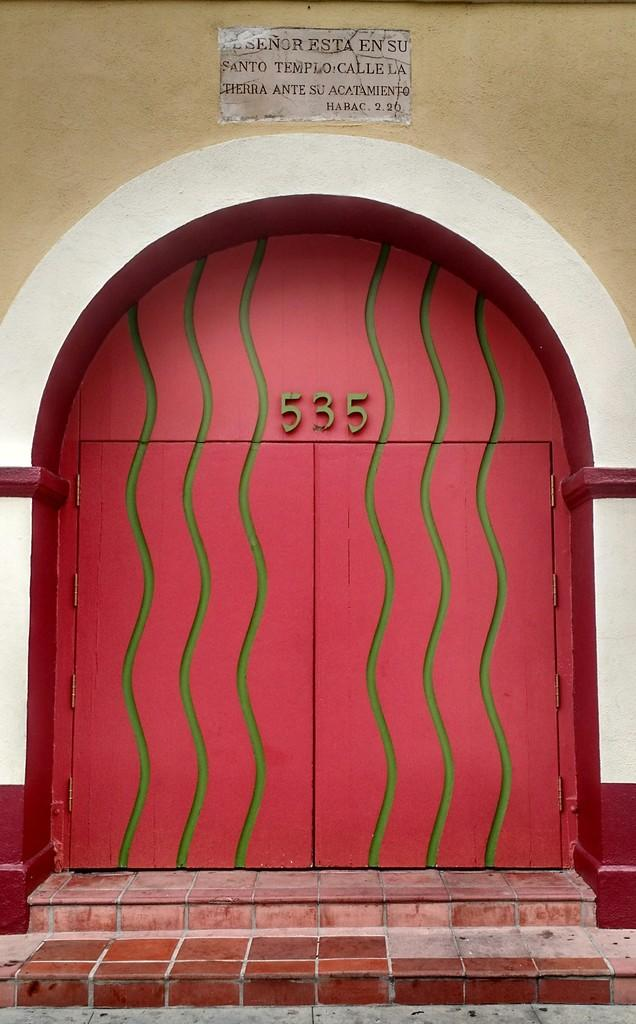What is on the door in the image? There are numbers on the door in the image. What can be found on the wall in the image? There is a marble with text on a wall in the image. What architectural feature is present in the image? There are stairs in the image. How many cows are visible in the image? There are no cows present in the image. What type of hat is the person wearing in the image? There is no person or hat visible in the image. 